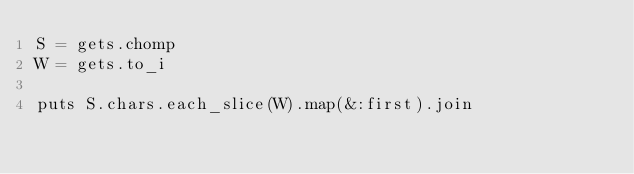<code> <loc_0><loc_0><loc_500><loc_500><_Ruby_>S = gets.chomp
W = gets.to_i

puts S.chars.each_slice(W).map(&:first).join
</code> 